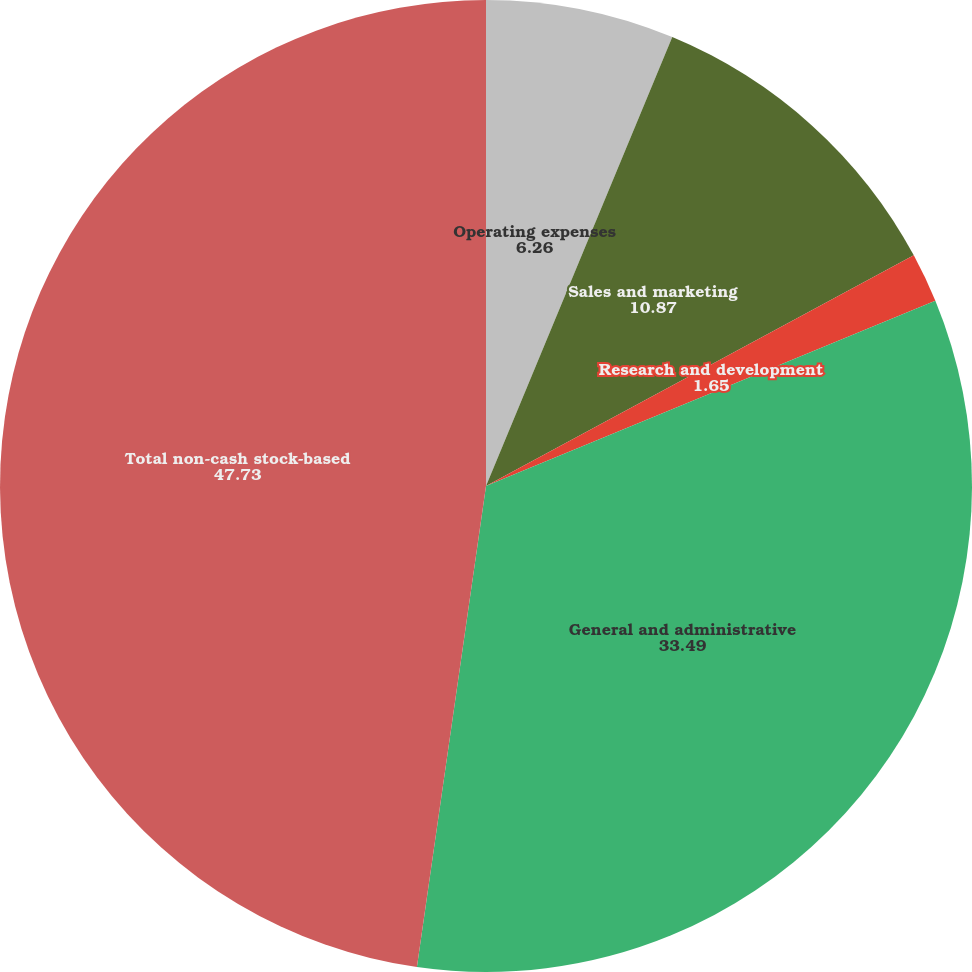Convert chart to OTSL. <chart><loc_0><loc_0><loc_500><loc_500><pie_chart><fcel>Operating expenses<fcel>Sales and marketing<fcel>Research and development<fcel>General and administrative<fcel>Total non-cash stock-based<nl><fcel>6.26%<fcel>10.87%<fcel>1.65%<fcel>33.49%<fcel>47.73%<nl></chart> 